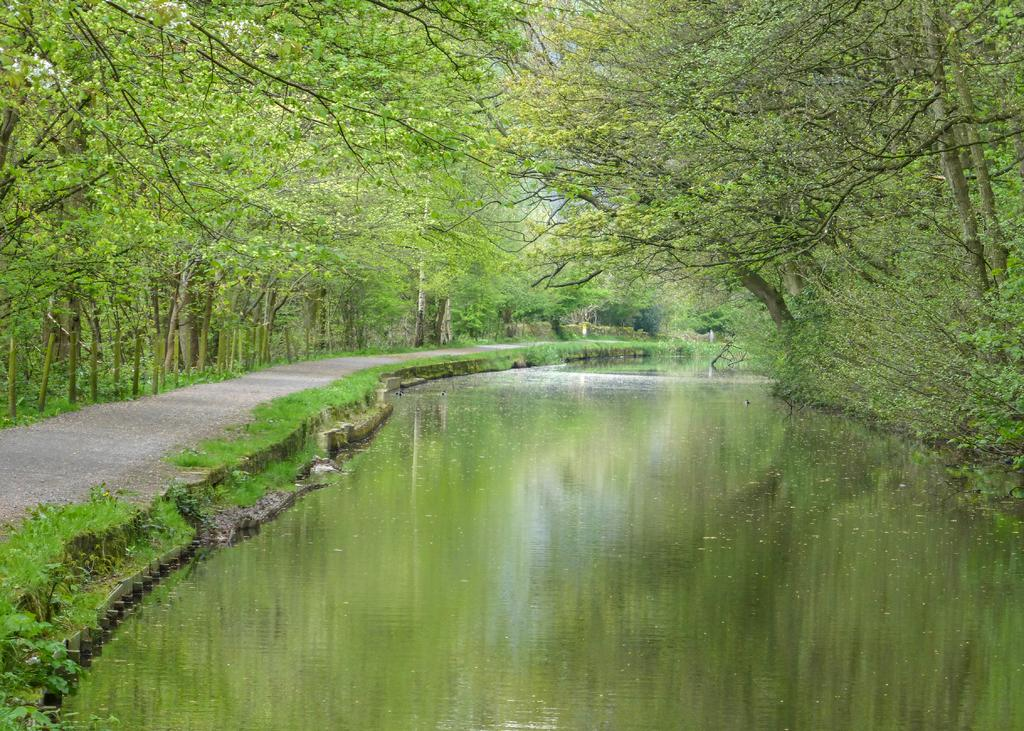What is one of the natural elements present in the image? There is water in the image. What type of vegetation can be seen in the image? There is grass in the image. What type of man-made structure is visible in the image? There is a road in the image. What other natural elements can be seen in the image? There are trees in the image. Where is the store located in the image? There is no store present in the image. What type of beach can be seen in the image? There is no seashore or beach present in the image. 